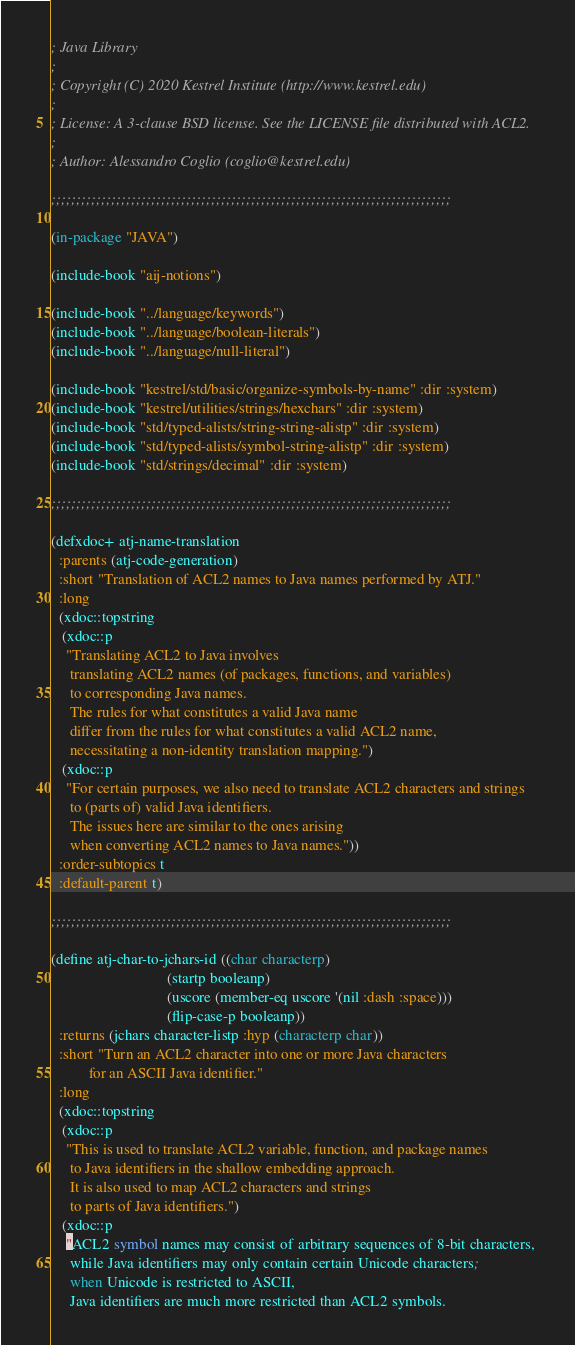Convert code to text. <code><loc_0><loc_0><loc_500><loc_500><_Lisp_>; Java Library
;
; Copyright (C) 2020 Kestrel Institute (http://www.kestrel.edu)
;
; License: A 3-clause BSD license. See the LICENSE file distributed with ACL2.
;
; Author: Alessandro Coglio (coglio@kestrel.edu)

;;;;;;;;;;;;;;;;;;;;;;;;;;;;;;;;;;;;;;;;;;;;;;;;;;;;;;;;;;;;;;;;;;;;;;;;;;;;;;;;

(in-package "JAVA")

(include-book "aij-notions")

(include-book "../language/keywords")
(include-book "../language/boolean-literals")
(include-book "../language/null-literal")

(include-book "kestrel/std/basic/organize-symbols-by-name" :dir :system)
(include-book "kestrel/utilities/strings/hexchars" :dir :system)
(include-book "std/typed-alists/string-string-alistp" :dir :system)
(include-book "std/typed-alists/symbol-string-alistp" :dir :system)
(include-book "std/strings/decimal" :dir :system)

;;;;;;;;;;;;;;;;;;;;;;;;;;;;;;;;;;;;;;;;;;;;;;;;;;;;;;;;;;;;;;;;;;;;;;;;;;;;;;;;

(defxdoc+ atj-name-translation
  :parents (atj-code-generation)
  :short "Translation of ACL2 names to Java names performed by ATJ."
  :long
  (xdoc::topstring
   (xdoc::p
    "Translating ACL2 to Java involves
     translating ACL2 names (of packages, functions, and variables)
     to corresponding Java names.
     The rules for what constitutes a valid Java name
     differ from the rules for what constitutes a valid ACL2 name,
     necessitating a non-identity translation mapping.")
   (xdoc::p
    "For certain purposes, we also need to translate ACL2 characters and strings
     to (parts of) valid Java identifiers.
     The issues here are similar to the ones arising
     when converting ACL2 names to Java names."))
  :order-subtopics t
  :default-parent t)

;;;;;;;;;;;;;;;;;;;;;;;;;;;;;;;;;;;;;;;;;;;;;;;;;;;;;;;;;;;;;;;;;;;;;;;;;;;;;;;;

(define atj-char-to-jchars-id ((char characterp)
                               (startp booleanp)
                               (uscore (member-eq uscore '(nil :dash :space)))
                               (flip-case-p booleanp))
  :returns (jchars character-listp :hyp (characterp char))
  :short "Turn an ACL2 character into one or more Java characters
          for an ASCII Java identifier."
  :long
  (xdoc::topstring
   (xdoc::p
    "This is used to translate ACL2 variable, function, and package names
     to Java identifiers in the shallow embedding approach.
     It is also used to map ACL2 characters and strings
     to parts of Java identifiers.")
   (xdoc::p
    "ACL2 symbol names may consist of arbitrary sequences of 8-bit characters,
     while Java identifiers may only contain certain Unicode characters;
     when Unicode is restricted to ASCII,
     Java identifiers are much more restricted than ACL2 symbols.</code> 